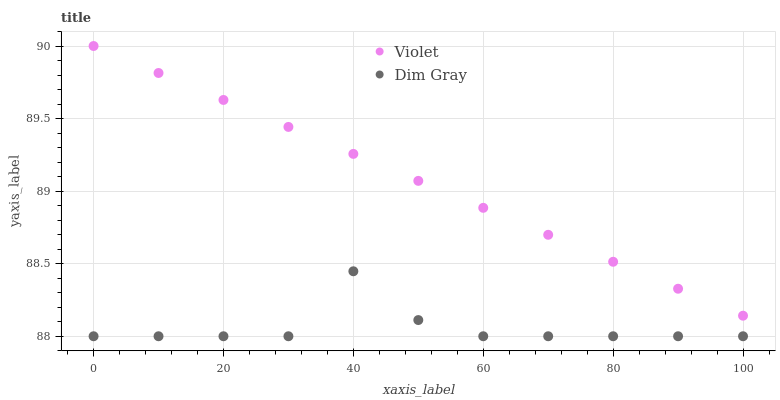Does Dim Gray have the minimum area under the curve?
Answer yes or no. Yes. Does Violet have the maximum area under the curve?
Answer yes or no. Yes. Does Violet have the minimum area under the curve?
Answer yes or no. No. Is Violet the smoothest?
Answer yes or no. Yes. Is Dim Gray the roughest?
Answer yes or no. Yes. Is Violet the roughest?
Answer yes or no. No. Does Dim Gray have the lowest value?
Answer yes or no. Yes. Does Violet have the lowest value?
Answer yes or no. No. Does Violet have the highest value?
Answer yes or no. Yes. Is Dim Gray less than Violet?
Answer yes or no. Yes. Is Violet greater than Dim Gray?
Answer yes or no. Yes. Does Dim Gray intersect Violet?
Answer yes or no. No. 